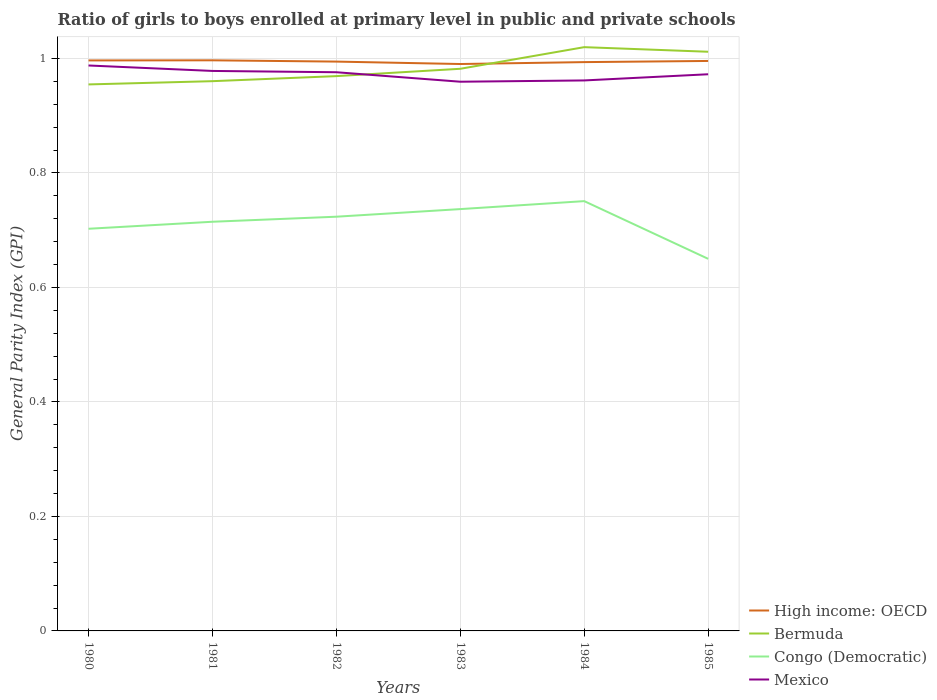How many different coloured lines are there?
Offer a very short reply. 4. Does the line corresponding to Mexico intersect with the line corresponding to High income: OECD?
Give a very brief answer. No. Across all years, what is the maximum general parity index in High income: OECD?
Make the answer very short. 0.99. In which year was the general parity index in Mexico maximum?
Provide a succinct answer. 1983. What is the total general parity index in Bermuda in the graph?
Provide a short and direct response. -0.07. What is the difference between the highest and the second highest general parity index in Mexico?
Ensure brevity in your answer.  0.03. How many years are there in the graph?
Offer a terse response. 6. Are the values on the major ticks of Y-axis written in scientific E-notation?
Offer a very short reply. No. Does the graph contain grids?
Your answer should be compact. Yes. Where does the legend appear in the graph?
Offer a terse response. Bottom right. How are the legend labels stacked?
Offer a very short reply. Vertical. What is the title of the graph?
Provide a short and direct response. Ratio of girls to boys enrolled at primary level in public and private schools. What is the label or title of the X-axis?
Keep it short and to the point. Years. What is the label or title of the Y-axis?
Offer a very short reply. General Parity Index (GPI). What is the General Parity Index (GPI) of High income: OECD in 1980?
Your answer should be very brief. 1. What is the General Parity Index (GPI) in Bermuda in 1980?
Your answer should be compact. 0.95. What is the General Parity Index (GPI) of Congo (Democratic) in 1980?
Ensure brevity in your answer.  0.7. What is the General Parity Index (GPI) of Mexico in 1980?
Offer a terse response. 0.99. What is the General Parity Index (GPI) in High income: OECD in 1981?
Your response must be concise. 1. What is the General Parity Index (GPI) in Bermuda in 1981?
Ensure brevity in your answer.  0.96. What is the General Parity Index (GPI) in Congo (Democratic) in 1981?
Ensure brevity in your answer.  0.71. What is the General Parity Index (GPI) of Mexico in 1981?
Ensure brevity in your answer.  0.98. What is the General Parity Index (GPI) of High income: OECD in 1982?
Give a very brief answer. 0.99. What is the General Parity Index (GPI) in Bermuda in 1982?
Make the answer very short. 0.97. What is the General Parity Index (GPI) of Congo (Democratic) in 1982?
Make the answer very short. 0.72. What is the General Parity Index (GPI) of Mexico in 1982?
Give a very brief answer. 0.98. What is the General Parity Index (GPI) in High income: OECD in 1983?
Offer a very short reply. 0.99. What is the General Parity Index (GPI) in Bermuda in 1983?
Offer a terse response. 0.98. What is the General Parity Index (GPI) of Congo (Democratic) in 1983?
Your response must be concise. 0.74. What is the General Parity Index (GPI) of Mexico in 1983?
Offer a very short reply. 0.96. What is the General Parity Index (GPI) in High income: OECD in 1984?
Provide a short and direct response. 0.99. What is the General Parity Index (GPI) in Bermuda in 1984?
Your response must be concise. 1.02. What is the General Parity Index (GPI) in Congo (Democratic) in 1984?
Keep it short and to the point. 0.75. What is the General Parity Index (GPI) in Mexico in 1984?
Provide a succinct answer. 0.96. What is the General Parity Index (GPI) of High income: OECD in 1985?
Keep it short and to the point. 1. What is the General Parity Index (GPI) in Bermuda in 1985?
Offer a terse response. 1.01. What is the General Parity Index (GPI) in Congo (Democratic) in 1985?
Ensure brevity in your answer.  0.65. What is the General Parity Index (GPI) of Mexico in 1985?
Keep it short and to the point. 0.97. Across all years, what is the maximum General Parity Index (GPI) in High income: OECD?
Make the answer very short. 1. Across all years, what is the maximum General Parity Index (GPI) in Bermuda?
Offer a very short reply. 1.02. Across all years, what is the maximum General Parity Index (GPI) in Congo (Democratic)?
Ensure brevity in your answer.  0.75. Across all years, what is the maximum General Parity Index (GPI) in Mexico?
Your answer should be compact. 0.99. Across all years, what is the minimum General Parity Index (GPI) of High income: OECD?
Keep it short and to the point. 0.99. Across all years, what is the minimum General Parity Index (GPI) in Bermuda?
Make the answer very short. 0.95. Across all years, what is the minimum General Parity Index (GPI) of Congo (Democratic)?
Your answer should be compact. 0.65. Across all years, what is the minimum General Parity Index (GPI) in Mexico?
Ensure brevity in your answer.  0.96. What is the total General Parity Index (GPI) of High income: OECD in the graph?
Provide a succinct answer. 5.97. What is the total General Parity Index (GPI) of Bermuda in the graph?
Offer a terse response. 5.9. What is the total General Parity Index (GPI) of Congo (Democratic) in the graph?
Keep it short and to the point. 4.28. What is the total General Parity Index (GPI) of Mexico in the graph?
Your response must be concise. 5.84. What is the difference between the General Parity Index (GPI) in High income: OECD in 1980 and that in 1981?
Your answer should be compact. -0. What is the difference between the General Parity Index (GPI) of Bermuda in 1980 and that in 1981?
Ensure brevity in your answer.  -0.01. What is the difference between the General Parity Index (GPI) in Congo (Democratic) in 1980 and that in 1981?
Provide a short and direct response. -0.01. What is the difference between the General Parity Index (GPI) of Mexico in 1980 and that in 1981?
Offer a terse response. 0.01. What is the difference between the General Parity Index (GPI) of High income: OECD in 1980 and that in 1982?
Your response must be concise. 0. What is the difference between the General Parity Index (GPI) of Bermuda in 1980 and that in 1982?
Your response must be concise. -0.01. What is the difference between the General Parity Index (GPI) in Congo (Democratic) in 1980 and that in 1982?
Offer a terse response. -0.02. What is the difference between the General Parity Index (GPI) in Mexico in 1980 and that in 1982?
Give a very brief answer. 0.01. What is the difference between the General Parity Index (GPI) of High income: OECD in 1980 and that in 1983?
Offer a terse response. 0.01. What is the difference between the General Parity Index (GPI) in Bermuda in 1980 and that in 1983?
Make the answer very short. -0.03. What is the difference between the General Parity Index (GPI) in Congo (Democratic) in 1980 and that in 1983?
Make the answer very short. -0.03. What is the difference between the General Parity Index (GPI) of Mexico in 1980 and that in 1983?
Give a very brief answer. 0.03. What is the difference between the General Parity Index (GPI) of High income: OECD in 1980 and that in 1984?
Provide a succinct answer. 0. What is the difference between the General Parity Index (GPI) in Bermuda in 1980 and that in 1984?
Give a very brief answer. -0.07. What is the difference between the General Parity Index (GPI) of Congo (Democratic) in 1980 and that in 1984?
Your answer should be compact. -0.05. What is the difference between the General Parity Index (GPI) in Mexico in 1980 and that in 1984?
Offer a very short reply. 0.03. What is the difference between the General Parity Index (GPI) of High income: OECD in 1980 and that in 1985?
Ensure brevity in your answer.  0. What is the difference between the General Parity Index (GPI) in Bermuda in 1980 and that in 1985?
Your answer should be compact. -0.06. What is the difference between the General Parity Index (GPI) of Congo (Democratic) in 1980 and that in 1985?
Your answer should be very brief. 0.05. What is the difference between the General Parity Index (GPI) of Mexico in 1980 and that in 1985?
Provide a succinct answer. 0.02. What is the difference between the General Parity Index (GPI) of High income: OECD in 1981 and that in 1982?
Your answer should be very brief. 0. What is the difference between the General Parity Index (GPI) in Bermuda in 1981 and that in 1982?
Provide a short and direct response. -0.01. What is the difference between the General Parity Index (GPI) of Congo (Democratic) in 1981 and that in 1982?
Your answer should be compact. -0.01. What is the difference between the General Parity Index (GPI) in Mexico in 1981 and that in 1982?
Your response must be concise. 0. What is the difference between the General Parity Index (GPI) in High income: OECD in 1981 and that in 1983?
Ensure brevity in your answer.  0.01. What is the difference between the General Parity Index (GPI) of Bermuda in 1981 and that in 1983?
Your answer should be compact. -0.02. What is the difference between the General Parity Index (GPI) in Congo (Democratic) in 1981 and that in 1983?
Keep it short and to the point. -0.02. What is the difference between the General Parity Index (GPI) in Mexico in 1981 and that in 1983?
Give a very brief answer. 0.02. What is the difference between the General Parity Index (GPI) in High income: OECD in 1981 and that in 1984?
Your answer should be very brief. 0. What is the difference between the General Parity Index (GPI) of Bermuda in 1981 and that in 1984?
Ensure brevity in your answer.  -0.06. What is the difference between the General Parity Index (GPI) of Congo (Democratic) in 1981 and that in 1984?
Your answer should be compact. -0.04. What is the difference between the General Parity Index (GPI) of Mexico in 1981 and that in 1984?
Offer a terse response. 0.02. What is the difference between the General Parity Index (GPI) of High income: OECD in 1981 and that in 1985?
Keep it short and to the point. 0. What is the difference between the General Parity Index (GPI) of Bermuda in 1981 and that in 1985?
Offer a terse response. -0.05. What is the difference between the General Parity Index (GPI) of Congo (Democratic) in 1981 and that in 1985?
Offer a terse response. 0.06. What is the difference between the General Parity Index (GPI) of Mexico in 1981 and that in 1985?
Give a very brief answer. 0.01. What is the difference between the General Parity Index (GPI) in High income: OECD in 1982 and that in 1983?
Ensure brevity in your answer.  0. What is the difference between the General Parity Index (GPI) of Bermuda in 1982 and that in 1983?
Offer a very short reply. -0.01. What is the difference between the General Parity Index (GPI) of Congo (Democratic) in 1982 and that in 1983?
Keep it short and to the point. -0.01. What is the difference between the General Parity Index (GPI) of Mexico in 1982 and that in 1983?
Ensure brevity in your answer.  0.02. What is the difference between the General Parity Index (GPI) of High income: OECD in 1982 and that in 1984?
Your response must be concise. 0. What is the difference between the General Parity Index (GPI) in Bermuda in 1982 and that in 1984?
Offer a very short reply. -0.05. What is the difference between the General Parity Index (GPI) in Congo (Democratic) in 1982 and that in 1984?
Offer a terse response. -0.03. What is the difference between the General Parity Index (GPI) of Mexico in 1982 and that in 1984?
Your response must be concise. 0.01. What is the difference between the General Parity Index (GPI) in High income: OECD in 1982 and that in 1985?
Offer a very short reply. -0. What is the difference between the General Parity Index (GPI) of Bermuda in 1982 and that in 1985?
Your answer should be compact. -0.04. What is the difference between the General Parity Index (GPI) in Congo (Democratic) in 1982 and that in 1985?
Provide a short and direct response. 0.07. What is the difference between the General Parity Index (GPI) of Mexico in 1982 and that in 1985?
Your answer should be very brief. 0. What is the difference between the General Parity Index (GPI) in High income: OECD in 1983 and that in 1984?
Make the answer very short. -0. What is the difference between the General Parity Index (GPI) in Bermuda in 1983 and that in 1984?
Make the answer very short. -0.04. What is the difference between the General Parity Index (GPI) in Congo (Democratic) in 1983 and that in 1984?
Make the answer very short. -0.01. What is the difference between the General Parity Index (GPI) of Mexico in 1983 and that in 1984?
Your response must be concise. -0. What is the difference between the General Parity Index (GPI) in High income: OECD in 1983 and that in 1985?
Your answer should be compact. -0.01. What is the difference between the General Parity Index (GPI) of Bermuda in 1983 and that in 1985?
Offer a very short reply. -0.03. What is the difference between the General Parity Index (GPI) in Congo (Democratic) in 1983 and that in 1985?
Provide a succinct answer. 0.09. What is the difference between the General Parity Index (GPI) of Mexico in 1983 and that in 1985?
Offer a very short reply. -0.01. What is the difference between the General Parity Index (GPI) of High income: OECD in 1984 and that in 1985?
Keep it short and to the point. -0. What is the difference between the General Parity Index (GPI) in Bermuda in 1984 and that in 1985?
Provide a succinct answer. 0.01. What is the difference between the General Parity Index (GPI) of Congo (Democratic) in 1984 and that in 1985?
Give a very brief answer. 0.1. What is the difference between the General Parity Index (GPI) of Mexico in 1984 and that in 1985?
Make the answer very short. -0.01. What is the difference between the General Parity Index (GPI) of High income: OECD in 1980 and the General Parity Index (GPI) of Bermuda in 1981?
Your answer should be very brief. 0.04. What is the difference between the General Parity Index (GPI) in High income: OECD in 1980 and the General Parity Index (GPI) in Congo (Democratic) in 1981?
Offer a very short reply. 0.28. What is the difference between the General Parity Index (GPI) in High income: OECD in 1980 and the General Parity Index (GPI) in Mexico in 1981?
Your response must be concise. 0.02. What is the difference between the General Parity Index (GPI) of Bermuda in 1980 and the General Parity Index (GPI) of Congo (Democratic) in 1981?
Give a very brief answer. 0.24. What is the difference between the General Parity Index (GPI) of Bermuda in 1980 and the General Parity Index (GPI) of Mexico in 1981?
Your answer should be compact. -0.02. What is the difference between the General Parity Index (GPI) of Congo (Democratic) in 1980 and the General Parity Index (GPI) of Mexico in 1981?
Your answer should be very brief. -0.28. What is the difference between the General Parity Index (GPI) in High income: OECD in 1980 and the General Parity Index (GPI) in Bermuda in 1982?
Give a very brief answer. 0.03. What is the difference between the General Parity Index (GPI) of High income: OECD in 1980 and the General Parity Index (GPI) of Congo (Democratic) in 1982?
Your response must be concise. 0.27. What is the difference between the General Parity Index (GPI) in High income: OECD in 1980 and the General Parity Index (GPI) in Mexico in 1982?
Offer a very short reply. 0.02. What is the difference between the General Parity Index (GPI) in Bermuda in 1980 and the General Parity Index (GPI) in Congo (Democratic) in 1982?
Your answer should be compact. 0.23. What is the difference between the General Parity Index (GPI) in Bermuda in 1980 and the General Parity Index (GPI) in Mexico in 1982?
Offer a very short reply. -0.02. What is the difference between the General Parity Index (GPI) in Congo (Democratic) in 1980 and the General Parity Index (GPI) in Mexico in 1982?
Your answer should be compact. -0.27. What is the difference between the General Parity Index (GPI) of High income: OECD in 1980 and the General Parity Index (GPI) of Bermuda in 1983?
Keep it short and to the point. 0.01. What is the difference between the General Parity Index (GPI) in High income: OECD in 1980 and the General Parity Index (GPI) in Congo (Democratic) in 1983?
Make the answer very short. 0.26. What is the difference between the General Parity Index (GPI) of High income: OECD in 1980 and the General Parity Index (GPI) of Mexico in 1983?
Keep it short and to the point. 0.04. What is the difference between the General Parity Index (GPI) in Bermuda in 1980 and the General Parity Index (GPI) in Congo (Democratic) in 1983?
Provide a succinct answer. 0.22. What is the difference between the General Parity Index (GPI) of Bermuda in 1980 and the General Parity Index (GPI) of Mexico in 1983?
Your response must be concise. -0. What is the difference between the General Parity Index (GPI) in Congo (Democratic) in 1980 and the General Parity Index (GPI) in Mexico in 1983?
Your answer should be very brief. -0.26. What is the difference between the General Parity Index (GPI) in High income: OECD in 1980 and the General Parity Index (GPI) in Bermuda in 1984?
Your answer should be compact. -0.02. What is the difference between the General Parity Index (GPI) in High income: OECD in 1980 and the General Parity Index (GPI) in Congo (Democratic) in 1984?
Your response must be concise. 0.25. What is the difference between the General Parity Index (GPI) of High income: OECD in 1980 and the General Parity Index (GPI) of Mexico in 1984?
Offer a terse response. 0.04. What is the difference between the General Parity Index (GPI) of Bermuda in 1980 and the General Parity Index (GPI) of Congo (Democratic) in 1984?
Offer a terse response. 0.2. What is the difference between the General Parity Index (GPI) of Bermuda in 1980 and the General Parity Index (GPI) of Mexico in 1984?
Give a very brief answer. -0.01. What is the difference between the General Parity Index (GPI) of Congo (Democratic) in 1980 and the General Parity Index (GPI) of Mexico in 1984?
Offer a very short reply. -0.26. What is the difference between the General Parity Index (GPI) in High income: OECD in 1980 and the General Parity Index (GPI) in Bermuda in 1985?
Ensure brevity in your answer.  -0.02. What is the difference between the General Parity Index (GPI) in High income: OECD in 1980 and the General Parity Index (GPI) in Congo (Democratic) in 1985?
Keep it short and to the point. 0.35. What is the difference between the General Parity Index (GPI) of High income: OECD in 1980 and the General Parity Index (GPI) of Mexico in 1985?
Your answer should be very brief. 0.02. What is the difference between the General Parity Index (GPI) of Bermuda in 1980 and the General Parity Index (GPI) of Congo (Democratic) in 1985?
Provide a succinct answer. 0.3. What is the difference between the General Parity Index (GPI) in Bermuda in 1980 and the General Parity Index (GPI) in Mexico in 1985?
Provide a short and direct response. -0.02. What is the difference between the General Parity Index (GPI) of Congo (Democratic) in 1980 and the General Parity Index (GPI) of Mexico in 1985?
Give a very brief answer. -0.27. What is the difference between the General Parity Index (GPI) of High income: OECD in 1981 and the General Parity Index (GPI) of Bermuda in 1982?
Ensure brevity in your answer.  0.03. What is the difference between the General Parity Index (GPI) in High income: OECD in 1981 and the General Parity Index (GPI) in Congo (Democratic) in 1982?
Offer a terse response. 0.27. What is the difference between the General Parity Index (GPI) of High income: OECD in 1981 and the General Parity Index (GPI) of Mexico in 1982?
Provide a succinct answer. 0.02. What is the difference between the General Parity Index (GPI) of Bermuda in 1981 and the General Parity Index (GPI) of Congo (Democratic) in 1982?
Provide a succinct answer. 0.24. What is the difference between the General Parity Index (GPI) of Bermuda in 1981 and the General Parity Index (GPI) of Mexico in 1982?
Keep it short and to the point. -0.02. What is the difference between the General Parity Index (GPI) of Congo (Democratic) in 1981 and the General Parity Index (GPI) of Mexico in 1982?
Your answer should be very brief. -0.26. What is the difference between the General Parity Index (GPI) in High income: OECD in 1981 and the General Parity Index (GPI) in Bermuda in 1983?
Provide a succinct answer. 0.01. What is the difference between the General Parity Index (GPI) in High income: OECD in 1981 and the General Parity Index (GPI) in Congo (Democratic) in 1983?
Your answer should be very brief. 0.26. What is the difference between the General Parity Index (GPI) in High income: OECD in 1981 and the General Parity Index (GPI) in Mexico in 1983?
Make the answer very short. 0.04. What is the difference between the General Parity Index (GPI) in Bermuda in 1981 and the General Parity Index (GPI) in Congo (Democratic) in 1983?
Offer a terse response. 0.22. What is the difference between the General Parity Index (GPI) in Congo (Democratic) in 1981 and the General Parity Index (GPI) in Mexico in 1983?
Your response must be concise. -0.24. What is the difference between the General Parity Index (GPI) of High income: OECD in 1981 and the General Parity Index (GPI) of Bermuda in 1984?
Offer a terse response. -0.02. What is the difference between the General Parity Index (GPI) in High income: OECD in 1981 and the General Parity Index (GPI) in Congo (Democratic) in 1984?
Keep it short and to the point. 0.25. What is the difference between the General Parity Index (GPI) of High income: OECD in 1981 and the General Parity Index (GPI) of Mexico in 1984?
Offer a terse response. 0.04. What is the difference between the General Parity Index (GPI) in Bermuda in 1981 and the General Parity Index (GPI) in Congo (Democratic) in 1984?
Keep it short and to the point. 0.21. What is the difference between the General Parity Index (GPI) of Bermuda in 1981 and the General Parity Index (GPI) of Mexico in 1984?
Offer a very short reply. -0. What is the difference between the General Parity Index (GPI) in Congo (Democratic) in 1981 and the General Parity Index (GPI) in Mexico in 1984?
Keep it short and to the point. -0.25. What is the difference between the General Parity Index (GPI) in High income: OECD in 1981 and the General Parity Index (GPI) in Bermuda in 1985?
Make the answer very short. -0.01. What is the difference between the General Parity Index (GPI) in High income: OECD in 1981 and the General Parity Index (GPI) in Congo (Democratic) in 1985?
Give a very brief answer. 0.35. What is the difference between the General Parity Index (GPI) of High income: OECD in 1981 and the General Parity Index (GPI) of Mexico in 1985?
Your response must be concise. 0.02. What is the difference between the General Parity Index (GPI) in Bermuda in 1981 and the General Parity Index (GPI) in Congo (Democratic) in 1985?
Give a very brief answer. 0.31. What is the difference between the General Parity Index (GPI) in Bermuda in 1981 and the General Parity Index (GPI) in Mexico in 1985?
Provide a succinct answer. -0.01. What is the difference between the General Parity Index (GPI) in Congo (Democratic) in 1981 and the General Parity Index (GPI) in Mexico in 1985?
Make the answer very short. -0.26. What is the difference between the General Parity Index (GPI) in High income: OECD in 1982 and the General Parity Index (GPI) in Bermuda in 1983?
Give a very brief answer. 0.01. What is the difference between the General Parity Index (GPI) in High income: OECD in 1982 and the General Parity Index (GPI) in Congo (Democratic) in 1983?
Make the answer very short. 0.26. What is the difference between the General Parity Index (GPI) in High income: OECD in 1982 and the General Parity Index (GPI) in Mexico in 1983?
Your response must be concise. 0.04. What is the difference between the General Parity Index (GPI) of Bermuda in 1982 and the General Parity Index (GPI) of Congo (Democratic) in 1983?
Your answer should be very brief. 0.23. What is the difference between the General Parity Index (GPI) in Bermuda in 1982 and the General Parity Index (GPI) in Mexico in 1983?
Give a very brief answer. 0.01. What is the difference between the General Parity Index (GPI) of Congo (Democratic) in 1982 and the General Parity Index (GPI) of Mexico in 1983?
Make the answer very short. -0.24. What is the difference between the General Parity Index (GPI) of High income: OECD in 1982 and the General Parity Index (GPI) of Bermuda in 1984?
Ensure brevity in your answer.  -0.03. What is the difference between the General Parity Index (GPI) of High income: OECD in 1982 and the General Parity Index (GPI) of Congo (Democratic) in 1984?
Offer a very short reply. 0.24. What is the difference between the General Parity Index (GPI) in High income: OECD in 1982 and the General Parity Index (GPI) in Mexico in 1984?
Make the answer very short. 0.03. What is the difference between the General Parity Index (GPI) in Bermuda in 1982 and the General Parity Index (GPI) in Congo (Democratic) in 1984?
Provide a succinct answer. 0.22. What is the difference between the General Parity Index (GPI) in Bermuda in 1982 and the General Parity Index (GPI) in Mexico in 1984?
Give a very brief answer. 0.01. What is the difference between the General Parity Index (GPI) in Congo (Democratic) in 1982 and the General Parity Index (GPI) in Mexico in 1984?
Provide a succinct answer. -0.24. What is the difference between the General Parity Index (GPI) of High income: OECD in 1982 and the General Parity Index (GPI) of Bermuda in 1985?
Give a very brief answer. -0.02. What is the difference between the General Parity Index (GPI) of High income: OECD in 1982 and the General Parity Index (GPI) of Congo (Democratic) in 1985?
Keep it short and to the point. 0.34. What is the difference between the General Parity Index (GPI) of High income: OECD in 1982 and the General Parity Index (GPI) of Mexico in 1985?
Provide a succinct answer. 0.02. What is the difference between the General Parity Index (GPI) of Bermuda in 1982 and the General Parity Index (GPI) of Congo (Democratic) in 1985?
Provide a succinct answer. 0.32. What is the difference between the General Parity Index (GPI) in Bermuda in 1982 and the General Parity Index (GPI) in Mexico in 1985?
Provide a short and direct response. -0. What is the difference between the General Parity Index (GPI) in Congo (Democratic) in 1982 and the General Parity Index (GPI) in Mexico in 1985?
Ensure brevity in your answer.  -0.25. What is the difference between the General Parity Index (GPI) of High income: OECD in 1983 and the General Parity Index (GPI) of Bermuda in 1984?
Your answer should be compact. -0.03. What is the difference between the General Parity Index (GPI) in High income: OECD in 1983 and the General Parity Index (GPI) in Congo (Democratic) in 1984?
Offer a terse response. 0.24. What is the difference between the General Parity Index (GPI) in High income: OECD in 1983 and the General Parity Index (GPI) in Mexico in 1984?
Provide a succinct answer. 0.03. What is the difference between the General Parity Index (GPI) of Bermuda in 1983 and the General Parity Index (GPI) of Congo (Democratic) in 1984?
Your answer should be compact. 0.23. What is the difference between the General Parity Index (GPI) of Bermuda in 1983 and the General Parity Index (GPI) of Mexico in 1984?
Keep it short and to the point. 0.02. What is the difference between the General Parity Index (GPI) in Congo (Democratic) in 1983 and the General Parity Index (GPI) in Mexico in 1984?
Offer a terse response. -0.22. What is the difference between the General Parity Index (GPI) in High income: OECD in 1983 and the General Parity Index (GPI) in Bermuda in 1985?
Offer a very short reply. -0.02. What is the difference between the General Parity Index (GPI) in High income: OECD in 1983 and the General Parity Index (GPI) in Congo (Democratic) in 1985?
Provide a short and direct response. 0.34. What is the difference between the General Parity Index (GPI) of High income: OECD in 1983 and the General Parity Index (GPI) of Mexico in 1985?
Provide a short and direct response. 0.02. What is the difference between the General Parity Index (GPI) of Bermuda in 1983 and the General Parity Index (GPI) of Congo (Democratic) in 1985?
Make the answer very short. 0.33. What is the difference between the General Parity Index (GPI) in Bermuda in 1983 and the General Parity Index (GPI) in Mexico in 1985?
Provide a succinct answer. 0.01. What is the difference between the General Parity Index (GPI) of Congo (Democratic) in 1983 and the General Parity Index (GPI) of Mexico in 1985?
Your answer should be compact. -0.24. What is the difference between the General Parity Index (GPI) in High income: OECD in 1984 and the General Parity Index (GPI) in Bermuda in 1985?
Keep it short and to the point. -0.02. What is the difference between the General Parity Index (GPI) of High income: OECD in 1984 and the General Parity Index (GPI) of Congo (Democratic) in 1985?
Give a very brief answer. 0.34. What is the difference between the General Parity Index (GPI) of High income: OECD in 1984 and the General Parity Index (GPI) of Mexico in 1985?
Your answer should be compact. 0.02. What is the difference between the General Parity Index (GPI) in Bermuda in 1984 and the General Parity Index (GPI) in Congo (Democratic) in 1985?
Make the answer very short. 0.37. What is the difference between the General Parity Index (GPI) in Bermuda in 1984 and the General Parity Index (GPI) in Mexico in 1985?
Your answer should be compact. 0.05. What is the difference between the General Parity Index (GPI) in Congo (Democratic) in 1984 and the General Parity Index (GPI) in Mexico in 1985?
Offer a terse response. -0.22. What is the average General Parity Index (GPI) of High income: OECD per year?
Offer a terse response. 0.99. What is the average General Parity Index (GPI) of Bermuda per year?
Give a very brief answer. 0.98. What is the average General Parity Index (GPI) in Congo (Democratic) per year?
Ensure brevity in your answer.  0.71. What is the average General Parity Index (GPI) of Mexico per year?
Make the answer very short. 0.97. In the year 1980, what is the difference between the General Parity Index (GPI) in High income: OECD and General Parity Index (GPI) in Bermuda?
Your answer should be very brief. 0.04. In the year 1980, what is the difference between the General Parity Index (GPI) of High income: OECD and General Parity Index (GPI) of Congo (Democratic)?
Your answer should be compact. 0.29. In the year 1980, what is the difference between the General Parity Index (GPI) in High income: OECD and General Parity Index (GPI) in Mexico?
Offer a very short reply. 0.01. In the year 1980, what is the difference between the General Parity Index (GPI) of Bermuda and General Parity Index (GPI) of Congo (Democratic)?
Ensure brevity in your answer.  0.25. In the year 1980, what is the difference between the General Parity Index (GPI) of Bermuda and General Parity Index (GPI) of Mexico?
Ensure brevity in your answer.  -0.03. In the year 1980, what is the difference between the General Parity Index (GPI) of Congo (Democratic) and General Parity Index (GPI) of Mexico?
Make the answer very short. -0.29. In the year 1981, what is the difference between the General Parity Index (GPI) of High income: OECD and General Parity Index (GPI) of Bermuda?
Your response must be concise. 0.04. In the year 1981, what is the difference between the General Parity Index (GPI) of High income: OECD and General Parity Index (GPI) of Congo (Democratic)?
Your answer should be compact. 0.28. In the year 1981, what is the difference between the General Parity Index (GPI) of High income: OECD and General Parity Index (GPI) of Mexico?
Your answer should be very brief. 0.02. In the year 1981, what is the difference between the General Parity Index (GPI) in Bermuda and General Parity Index (GPI) in Congo (Democratic)?
Make the answer very short. 0.25. In the year 1981, what is the difference between the General Parity Index (GPI) of Bermuda and General Parity Index (GPI) of Mexico?
Provide a short and direct response. -0.02. In the year 1981, what is the difference between the General Parity Index (GPI) of Congo (Democratic) and General Parity Index (GPI) of Mexico?
Keep it short and to the point. -0.26. In the year 1982, what is the difference between the General Parity Index (GPI) in High income: OECD and General Parity Index (GPI) in Bermuda?
Provide a short and direct response. 0.03. In the year 1982, what is the difference between the General Parity Index (GPI) in High income: OECD and General Parity Index (GPI) in Congo (Democratic)?
Provide a succinct answer. 0.27. In the year 1982, what is the difference between the General Parity Index (GPI) in High income: OECD and General Parity Index (GPI) in Mexico?
Offer a very short reply. 0.02. In the year 1982, what is the difference between the General Parity Index (GPI) of Bermuda and General Parity Index (GPI) of Congo (Democratic)?
Offer a terse response. 0.25. In the year 1982, what is the difference between the General Parity Index (GPI) of Bermuda and General Parity Index (GPI) of Mexico?
Your response must be concise. -0.01. In the year 1982, what is the difference between the General Parity Index (GPI) of Congo (Democratic) and General Parity Index (GPI) of Mexico?
Ensure brevity in your answer.  -0.25. In the year 1983, what is the difference between the General Parity Index (GPI) in High income: OECD and General Parity Index (GPI) in Bermuda?
Offer a very short reply. 0.01. In the year 1983, what is the difference between the General Parity Index (GPI) in High income: OECD and General Parity Index (GPI) in Congo (Democratic)?
Provide a short and direct response. 0.25. In the year 1983, what is the difference between the General Parity Index (GPI) in High income: OECD and General Parity Index (GPI) in Mexico?
Make the answer very short. 0.03. In the year 1983, what is the difference between the General Parity Index (GPI) of Bermuda and General Parity Index (GPI) of Congo (Democratic)?
Make the answer very short. 0.25. In the year 1983, what is the difference between the General Parity Index (GPI) in Bermuda and General Parity Index (GPI) in Mexico?
Your answer should be compact. 0.02. In the year 1983, what is the difference between the General Parity Index (GPI) in Congo (Democratic) and General Parity Index (GPI) in Mexico?
Your response must be concise. -0.22. In the year 1984, what is the difference between the General Parity Index (GPI) in High income: OECD and General Parity Index (GPI) in Bermuda?
Your answer should be compact. -0.03. In the year 1984, what is the difference between the General Parity Index (GPI) in High income: OECD and General Parity Index (GPI) in Congo (Democratic)?
Your answer should be very brief. 0.24. In the year 1984, what is the difference between the General Parity Index (GPI) of High income: OECD and General Parity Index (GPI) of Mexico?
Provide a succinct answer. 0.03. In the year 1984, what is the difference between the General Parity Index (GPI) of Bermuda and General Parity Index (GPI) of Congo (Democratic)?
Provide a short and direct response. 0.27. In the year 1984, what is the difference between the General Parity Index (GPI) in Bermuda and General Parity Index (GPI) in Mexico?
Your answer should be very brief. 0.06. In the year 1984, what is the difference between the General Parity Index (GPI) in Congo (Democratic) and General Parity Index (GPI) in Mexico?
Your response must be concise. -0.21. In the year 1985, what is the difference between the General Parity Index (GPI) in High income: OECD and General Parity Index (GPI) in Bermuda?
Ensure brevity in your answer.  -0.02. In the year 1985, what is the difference between the General Parity Index (GPI) in High income: OECD and General Parity Index (GPI) in Congo (Democratic)?
Offer a very short reply. 0.35. In the year 1985, what is the difference between the General Parity Index (GPI) of High income: OECD and General Parity Index (GPI) of Mexico?
Give a very brief answer. 0.02. In the year 1985, what is the difference between the General Parity Index (GPI) in Bermuda and General Parity Index (GPI) in Congo (Democratic)?
Make the answer very short. 0.36. In the year 1985, what is the difference between the General Parity Index (GPI) of Bermuda and General Parity Index (GPI) of Mexico?
Give a very brief answer. 0.04. In the year 1985, what is the difference between the General Parity Index (GPI) in Congo (Democratic) and General Parity Index (GPI) in Mexico?
Provide a succinct answer. -0.32. What is the ratio of the General Parity Index (GPI) of High income: OECD in 1980 to that in 1981?
Offer a terse response. 1. What is the ratio of the General Parity Index (GPI) in Bermuda in 1980 to that in 1981?
Offer a terse response. 0.99. What is the ratio of the General Parity Index (GPI) of Congo (Democratic) in 1980 to that in 1981?
Ensure brevity in your answer.  0.98. What is the ratio of the General Parity Index (GPI) of Mexico in 1980 to that in 1981?
Your response must be concise. 1.01. What is the ratio of the General Parity Index (GPI) of Bermuda in 1980 to that in 1982?
Give a very brief answer. 0.98. What is the ratio of the General Parity Index (GPI) of Congo (Democratic) in 1980 to that in 1982?
Ensure brevity in your answer.  0.97. What is the ratio of the General Parity Index (GPI) of Mexico in 1980 to that in 1982?
Your answer should be very brief. 1.01. What is the ratio of the General Parity Index (GPI) of Bermuda in 1980 to that in 1983?
Your answer should be very brief. 0.97. What is the ratio of the General Parity Index (GPI) of Congo (Democratic) in 1980 to that in 1983?
Keep it short and to the point. 0.95. What is the ratio of the General Parity Index (GPI) of Mexico in 1980 to that in 1983?
Make the answer very short. 1.03. What is the ratio of the General Parity Index (GPI) in Bermuda in 1980 to that in 1984?
Your answer should be very brief. 0.94. What is the ratio of the General Parity Index (GPI) of Congo (Democratic) in 1980 to that in 1984?
Provide a short and direct response. 0.94. What is the ratio of the General Parity Index (GPI) in Mexico in 1980 to that in 1984?
Provide a short and direct response. 1.03. What is the ratio of the General Parity Index (GPI) of Bermuda in 1980 to that in 1985?
Offer a very short reply. 0.94. What is the ratio of the General Parity Index (GPI) in Congo (Democratic) in 1980 to that in 1985?
Your answer should be very brief. 1.08. What is the ratio of the General Parity Index (GPI) of Mexico in 1980 to that in 1985?
Provide a short and direct response. 1.02. What is the ratio of the General Parity Index (GPI) in Bermuda in 1981 to that in 1982?
Your answer should be very brief. 0.99. What is the ratio of the General Parity Index (GPI) in High income: OECD in 1981 to that in 1983?
Offer a terse response. 1.01. What is the ratio of the General Parity Index (GPI) in Congo (Democratic) in 1981 to that in 1983?
Offer a very short reply. 0.97. What is the ratio of the General Parity Index (GPI) in Mexico in 1981 to that in 1983?
Offer a very short reply. 1.02. What is the ratio of the General Parity Index (GPI) in Bermuda in 1981 to that in 1984?
Your response must be concise. 0.94. What is the ratio of the General Parity Index (GPI) of Mexico in 1981 to that in 1984?
Your answer should be compact. 1.02. What is the ratio of the General Parity Index (GPI) of High income: OECD in 1981 to that in 1985?
Provide a short and direct response. 1. What is the ratio of the General Parity Index (GPI) in Bermuda in 1981 to that in 1985?
Your answer should be very brief. 0.95. What is the ratio of the General Parity Index (GPI) of Congo (Democratic) in 1981 to that in 1985?
Ensure brevity in your answer.  1.1. What is the ratio of the General Parity Index (GPI) in Congo (Democratic) in 1982 to that in 1983?
Offer a very short reply. 0.98. What is the ratio of the General Parity Index (GPI) of Mexico in 1982 to that in 1983?
Your answer should be compact. 1.02. What is the ratio of the General Parity Index (GPI) in High income: OECD in 1982 to that in 1984?
Your answer should be compact. 1. What is the ratio of the General Parity Index (GPI) in Bermuda in 1982 to that in 1984?
Provide a succinct answer. 0.95. What is the ratio of the General Parity Index (GPI) in Congo (Democratic) in 1982 to that in 1984?
Your answer should be very brief. 0.96. What is the ratio of the General Parity Index (GPI) in Mexico in 1982 to that in 1984?
Your answer should be very brief. 1.01. What is the ratio of the General Parity Index (GPI) in High income: OECD in 1982 to that in 1985?
Offer a very short reply. 1. What is the ratio of the General Parity Index (GPI) in Bermuda in 1982 to that in 1985?
Provide a succinct answer. 0.96. What is the ratio of the General Parity Index (GPI) in Congo (Democratic) in 1982 to that in 1985?
Offer a very short reply. 1.11. What is the ratio of the General Parity Index (GPI) of High income: OECD in 1983 to that in 1984?
Offer a terse response. 1. What is the ratio of the General Parity Index (GPI) in Congo (Democratic) in 1983 to that in 1984?
Your answer should be compact. 0.98. What is the ratio of the General Parity Index (GPI) in Bermuda in 1983 to that in 1985?
Provide a succinct answer. 0.97. What is the ratio of the General Parity Index (GPI) of Congo (Democratic) in 1983 to that in 1985?
Your response must be concise. 1.13. What is the ratio of the General Parity Index (GPI) in Mexico in 1983 to that in 1985?
Provide a short and direct response. 0.99. What is the ratio of the General Parity Index (GPI) in Bermuda in 1984 to that in 1985?
Your answer should be very brief. 1.01. What is the ratio of the General Parity Index (GPI) of Congo (Democratic) in 1984 to that in 1985?
Make the answer very short. 1.16. What is the ratio of the General Parity Index (GPI) of Mexico in 1984 to that in 1985?
Give a very brief answer. 0.99. What is the difference between the highest and the second highest General Parity Index (GPI) in Bermuda?
Make the answer very short. 0.01. What is the difference between the highest and the second highest General Parity Index (GPI) in Congo (Democratic)?
Keep it short and to the point. 0.01. What is the difference between the highest and the second highest General Parity Index (GPI) in Mexico?
Offer a terse response. 0.01. What is the difference between the highest and the lowest General Parity Index (GPI) in High income: OECD?
Your response must be concise. 0.01. What is the difference between the highest and the lowest General Parity Index (GPI) in Bermuda?
Give a very brief answer. 0.07. What is the difference between the highest and the lowest General Parity Index (GPI) in Congo (Democratic)?
Offer a very short reply. 0.1. What is the difference between the highest and the lowest General Parity Index (GPI) of Mexico?
Keep it short and to the point. 0.03. 